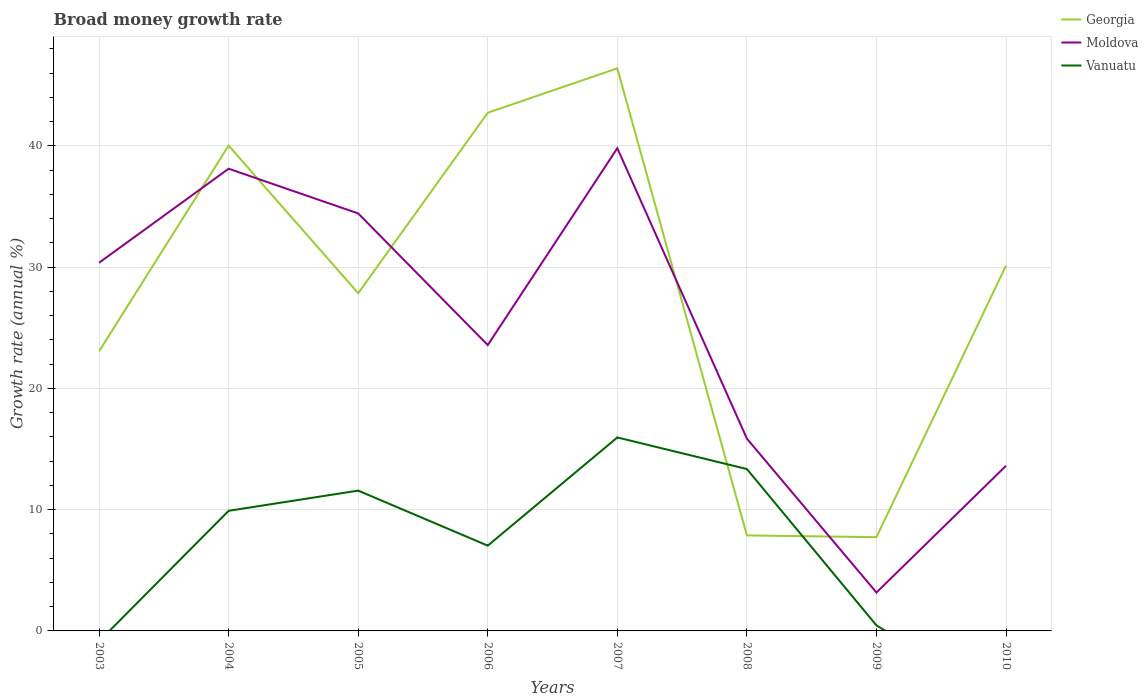Is the number of lines equal to the number of legend labels?
Make the answer very short. No. Across all years, what is the maximum growth rate in Vanuatu?
Your answer should be very brief. 0. What is the total growth rate in Moldova in the graph?
Offer a very short reply. 20.41. What is the difference between the highest and the second highest growth rate in Moldova?
Provide a short and direct response. 36.64. How many lines are there?
Your answer should be compact. 3. What is the difference between two consecutive major ticks on the Y-axis?
Provide a succinct answer. 10. Are the values on the major ticks of Y-axis written in scientific E-notation?
Your answer should be compact. No. How many legend labels are there?
Your answer should be compact. 3. How are the legend labels stacked?
Keep it short and to the point. Vertical. What is the title of the graph?
Offer a terse response. Broad money growth rate. Does "Portugal" appear as one of the legend labels in the graph?
Your answer should be very brief. No. What is the label or title of the X-axis?
Provide a succinct answer. Years. What is the label or title of the Y-axis?
Ensure brevity in your answer.  Growth rate (annual %). What is the Growth rate (annual %) of Georgia in 2003?
Your answer should be compact. 23.06. What is the Growth rate (annual %) in Moldova in 2003?
Ensure brevity in your answer.  30.37. What is the Growth rate (annual %) of Vanuatu in 2003?
Ensure brevity in your answer.  0. What is the Growth rate (annual %) in Georgia in 2004?
Offer a very short reply. 40.03. What is the Growth rate (annual %) of Moldova in 2004?
Ensure brevity in your answer.  38.12. What is the Growth rate (annual %) in Vanuatu in 2004?
Your answer should be very brief. 9.91. What is the Growth rate (annual %) in Georgia in 2005?
Your response must be concise. 27.85. What is the Growth rate (annual %) in Moldova in 2005?
Provide a short and direct response. 34.43. What is the Growth rate (annual %) in Vanuatu in 2005?
Keep it short and to the point. 11.57. What is the Growth rate (annual %) in Georgia in 2006?
Keep it short and to the point. 42.74. What is the Growth rate (annual %) in Moldova in 2006?
Make the answer very short. 23.58. What is the Growth rate (annual %) in Vanuatu in 2006?
Provide a short and direct response. 7.03. What is the Growth rate (annual %) in Georgia in 2007?
Make the answer very short. 46.4. What is the Growth rate (annual %) in Moldova in 2007?
Offer a very short reply. 39.81. What is the Growth rate (annual %) of Vanuatu in 2007?
Keep it short and to the point. 15.96. What is the Growth rate (annual %) of Georgia in 2008?
Ensure brevity in your answer.  7.88. What is the Growth rate (annual %) in Moldova in 2008?
Provide a short and direct response. 15.86. What is the Growth rate (annual %) of Vanuatu in 2008?
Your response must be concise. 13.35. What is the Growth rate (annual %) in Georgia in 2009?
Provide a succinct answer. 7.73. What is the Growth rate (annual %) in Moldova in 2009?
Your answer should be compact. 3.17. What is the Growth rate (annual %) of Vanuatu in 2009?
Provide a succinct answer. 0.46. What is the Growth rate (annual %) of Georgia in 2010?
Make the answer very short. 30.13. What is the Growth rate (annual %) of Moldova in 2010?
Provide a short and direct response. 13.62. What is the Growth rate (annual %) of Vanuatu in 2010?
Keep it short and to the point. 0. Across all years, what is the maximum Growth rate (annual %) of Georgia?
Give a very brief answer. 46.4. Across all years, what is the maximum Growth rate (annual %) in Moldova?
Your response must be concise. 39.81. Across all years, what is the maximum Growth rate (annual %) of Vanuatu?
Your answer should be compact. 15.96. Across all years, what is the minimum Growth rate (annual %) of Georgia?
Offer a very short reply. 7.73. Across all years, what is the minimum Growth rate (annual %) in Moldova?
Offer a terse response. 3.17. Across all years, what is the minimum Growth rate (annual %) in Vanuatu?
Offer a very short reply. 0. What is the total Growth rate (annual %) in Georgia in the graph?
Give a very brief answer. 225.82. What is the total Growth rate (annual %) in Moldova in the graph?
Give a very brief answer. 198.96. What is the total Growth rate (annual %) in Vanuatu in the graph?
Offer a very short reply. 58.28. What is the difference between the Growth rate (annual %) of Georgia in 2003 and that in 2004?
Provide a short and direct response. -16.97. What is the difference between the Growth rate (annual %) of Moldova in 2003 and that in 2004?
Ensure brevity in your answer.  -7.76. What is the difference between the Growth rate (annual %) in Georgia in 2003 and that in 2005?
Make the answer very short. -4.79. What is the difference between the Growth rate (annual %) of Moldova in 2003 and that in 2005?
Offer a very short reply. -4.07. What is the difference between the Growth rate (annual %) in Georgia in 2003 and that in 2006?
Make the answer very short. -19.67. What is the difference between the Growth rate (annual %) in Moldova in 2003 and that in 2006?
Keep it short and to the point. 6.79. What is the difference between the Growth rate (annual %) in Georgia in 2003 and that in 2007?
Your answer should be very brief. -23.34. What is the difference between the Growth rate (annual %) in Moldova in 2003 and that in 2007?
Give a very brief answer. -9.44. What is the difference between the Growth rate (annual %) of Georgia in 2003 and that in 2008?
Offer a terse response. 15.19. What is the difference between the Growth rate (annual %) in Moldova in 2003 and that in 2008?
Ensure brevity in your answer.  14.51. What is the difference between the Growth rate (annual %) of Georgia in 2003 and that in 2009?
Make the answer very short. 15.33. What is the difference between the Growth rate (annual %) of Moldova in 2003 and that in 2009?
Your answer should be very brief. 27.2. What is the difference between the Growth rate (annual %) of Georgia in 2003 and that in 2010?
Offer a very short reply. -7.07. What is the difference between the Growth rate (annual %) in Moldova in 2003 and that in 2010?
Your response must be concise. 16.74. What is the difference between the Growth rate (annual %) in Georgia in 2004 and that in 2005?
Offer a terse response. 12.18. What is the difference between the Growth rate (annual %) in Moldova in 2004 and that in 2005?
Ensure brevity in your answer.  3.69. What is the difference between the Growth rate (annual %) of Vanuatu in 2004 and that in 2005?
Provide a succinct answer. -1.66. What is the difference between the Growth rate (annual %) in Georgia in 2004 and that in 2006?
Your answer should be very brief. -2.71. What is the difference between the Growth rate (annual %) in Moldova in 2004 and that in 2006?
Make the answer very short. 14.55. What is the difference between the Growth rate (annual %) of Vanuatu in 2004 and that in 2006?
Your answer should be very brief. 2.87. What is the difference between the Growth rate (annual %) of Georgia in 2004 and that in 2007?
Your answer should be very brief. -6.37. What is the difference between the Growth rate (annual %) in Moldova in 2004 and that in 2007?
Your response must be concise. -1.69. What is the difference between the Growth rate (annual %) of Vanuatu in 2004 and that in 2007?
Offer a very short reply. -6.05. What is the difference between the Growth rate (annual %) of Georgia in 2004 and that in 2008?
Ensure brevity in your answer.  32.15. What is the difference between the Growth rate (annual %) in Moldova in 2004 and that in 2008?
Offer a terse response. 22.26. What is the difference between the Growth rate (annual %) in Vanuatu in 2004 and that in 2008?
Keep it short and to the point. -3.44. What is the difference between the Growth rate (annual %) in Georgia in 2004 and that in 2009?
Offer a very short reply. 32.3. What is the difference between the Growth rate (annual %) of Moldova in 2004 and that in 2009?
Give a very brief answer. 34.95. What is the difference between the Growth rate (annual %) of Vanuatu in 2004 and that in 2009?
Provide a succinct answer. 9.45. What is the difference between the Growth rate (annual %) of Georgia in 2004 and that in 2010?
Offer a very short reply. 9.9. What is the difference between the Growth rate (annual %) in Moldova in 2004 and that in 2010?
Offer a terse response. 24.5. What is the difference between the Growth rate (annual %) in Georgia in 2005 and that in 2006?
Keep it short and to the point. -14.88. What is the difference between the Growth rate (annual %) in Moldova in 2005 and that in 2006?
Ensure brevity in your answer.  10.86. What is the difference between the Growth rate (annual %) of Vanuatu in 2005 and that in 2006?
Your answer should be very brief. 4.54. What is the difference between the Growth rate (annual %) of Georgia in 2005 and that in 2007?
Your answer should be compact. -18.55. What is the difference between the Growth rate (annual %) in Moldova in 2005 and that in 2007?
Provide a short and direct response. -5.38. What is the difference between the Growth rate (annual %) in Vanuatu in 2005 and that in 2007?
Keep it short and to the point. -4.38. What is the difference between the Growth rate (annual %) in Georgia in 2005 and that in 2008?
Your answer should be very brief. 19.97. What is the difference between the Growth rate (annual %) of Moldova in 2005 and that in 2008?
Ensure brevity in your answer.  18.57. What is the difference between the Growth rate (annual %) in Vanuatu in 2005 and that in 2008?
Offer a terse response. -1.78. What is the difference between the Growth rate (annual %) of Georgia in 2005 and that in 2009?
Your response must be concise. 20.12. What is the difference between the Growth rate (annual %) in Moldova in 2005 and that in 2009?
Your response must be concise. 31.27. What is the difference between the Growth rate (annual %) of Vanuatu in 2005 and that in 2009?
Your answer should be compact. 11.12. What is the difference between the Growth rate (annual %) of Georgia in 2005 and that in 2010?
Your answer should be very brief. -2.28. What is the difference between the Growth rate (annual %) of Moldova in 2005 and that in 2010?
Provide a succinct answer. 20.81. What is the difference between the Growth rate (annual %) of Georgia in 2006 and that in 2007?
Offer a terse response. -3.66. What is the difference between the Growth rate (annual %) in Moldova in 2006 and that in 2007?
Keep it short and to the point. -16.23. What is the difference between the Growth rate (annual %) in Vanuatu in 2006 and that in 2007?
Ensure brevity in your answer.  -8.92. What is the difference between the Growth rate (annual %) in Georgia in 2006 and that in 2008?
Offer a terse response. 34.86. What is the difference between the Growth rate (annual %) of Moldova in 2006 and that in 2008?
Your answer should be very brief. 7.72. What is the difference between the Growth rate (annual %) of Vanuatu in 2006 and that in 2008?
Your answer should be very brief. -6.32. What is the difference between the Growth rate (annual %) in Georgia in 2006 and that in 2009?
Your answer should be very brief. 35. What is the difference between the Growth rate (annual %) in Moldova in 2006 and that in 2009?
Your answer should be very brief. 20.41. What is the difference between the Growth rate (annual %) of Vanuatu in 2006 and that in 2009?
Offer a terse response. 6.58. What is the difference between the Growth rate (annual %) of Georgia in 2006 and that in 2010?
Give a very brief answer. 12.6. What is the difference between the Growth rate (annual %) in Moldova in 2006 and that in 2010?
Ensure brevity in your answer.  9.95. What is the difference between the Growth rate (annual %) in Georgia in 2007 and that in 2008?
Your answer should be very brief. 38.52. What is the difference between the Growth rate (annual %) of Moldova in 2007 and that in 2008?
Offer a terse response. 23.95. What is the difference between the Growth rate (annual %) in Vanuatu in 2007 and that in 2008?
Your response must be concise. 2.61. What is the difference between the Growth rate (annual %) of Georgia in 2007 and that in 2009?
Offer a very short reply. 38.67. What is the difference between the Growth rate (annual %) of Moldova in 2007 and that in 2009?
Give a very brief answer. 36.64. What is the difference between the Growth rate (annual %) of Vanuatu in 2007 and that in 2009?
Offer a terse response. 15.5. What is the difference between the Growth rate (annual %) of Georgia in 2007 and that in 2010?
Make the answer very short. 16.27. What is the difference between the Growth rate (annual %) of Moldova in 2007 and that in 2010?
Keep it short and to the point. 26.19. What is the difference between the Growth rate (annual %) of Georgia in 2008 and that in 2009?
Your answer should be compact. 0.14. What is the difference between the Growth rate (annual %) of Moldova in 2008 and that in 2009?
Make the answer very short. 12.69. What is the difference between the Growth rate (annual %) of Vanuatu in 2008 and that in 2009?
Your answer should be very brief. 12.9. What is the difference between the Growth rate (annual %) in Georgia in 2008 and that in 2010?
Keep it short and to the point. -22.26. What is the difference between the Growth rate (annual %) of Moldova in 2008 and that in 2010?
Offer a very short reply. 2.24. What is the difference between the Growth rate (annual %) of Georgia in 2009 and that in 2010?
Offer a terse response. -22.4. What is the difference between the Growth rate (annual %) in Moldova in 2009 and that in 2010?
Your answer should be very brief. -10.45. What is the difference between the Growth rate (annual %) of Georgia in 2003 and the Growth rate (annual %) of Moldova in 2004?
Keep it short and to the point. -15.06. What is the difference between the Growth rate (annual %) of Georgia in 2003 and the Growth rate (annual %) of Vanuatu in 2004?
Make the answer very short. 13.15. What is the difference between the Growth rate (annual %) of Moldova in 2003 and the Growth rate (annual %) of Vanuatu in 2004?
Provide a short and direct response. 20.46. What is the difference between the Growth rate (annual %) in Georgia in 2003 and the Growth rate (annual %) in Moldova in 2005?
Offer a very short reply. -11.37. What is the difference between the Growth rate (annual %) in Georgia in 2003 and the Growth rate (annual %) in Vanuatu in 2005?
Offer a very short reply. 11.49. What is the difference between the Growth rate (annual %) of Moldova in 2003 and the Growth rate (annual %) of Vanuatu in 2005?
Your response must be concise. 18.79. What is the difference between the Growth rate (annual %) of Georgia in 2003 and the Growth rate (annual %) of Moldova in 2006?
Your answer should be compact. -0.51. What is the difference between the Growth rate (annual %) of Georgia in 2003 and the Growth rate (annual %) of Vanuatu in 2006?
Make the answer very short. 16.03. What is the difference between the Growth rate (annual %) of Moldova in 2003 and the Growth rate (annual %) of Vanuatu in 2006?
Ensure brevity in your answer.  23.33. What is the difference between the Growth rate (annual %) in Georgia in 2003 and the Growth rate (annual %) in Moldova in 2007?
Offer a terse response. -16.75. What is the difference between the Growth rate (annual %) of Georgia in 2003 and the Growth rate (annual %) of Vanuatu in 2007?
Offer a very short reply. 7.11. What is the difference between the Growth rate (annual %) of Moldova in 2003 and the Growth rate (annual %) of Vanuatu in 2007?
Your answer should be compact. 14.41. What is the difference between the Growth rate (annual %) in Georgia in 2003 and the Growth rate (annual %) in Moldova in 2008?
Provide a short and direct response. 7.2. What is the difference between the Growth rate (annual %) of Georgia in 2003 and the Growth rate (annual %) of Vanuatu in 2008?
Offer a terse response. 9.71. What is the difference between the Growth rate (annual %) of Moldova in 2003 and the Growth rate (annual %) of Vanuatu in 2008?
Your answer should be very brief. 17.01. What is the difference between the Growth rate (annual %) in Georgia in 2003 and the Growth rate (annual %) in Moldova in 2009?
Your response must be concise. 19.89. What is the difference between the Growth rate (annual %) in Georgia in 2003 and the Growth rate (annual %) in Vanuatu in 2009?
Offer a very short reply. 22.61. What is the difference between the Growth rate (annual %) of Moldova in 2003 and the Growth rate (annual %) of Vanuatu in 2009?
Your response must be concise. 29.91. What is the difference between the Growth rate (annual %) of Georgia in 2003 and the Growth rate (annual %) of Moldova in 2010?
Provide a short and direct response. 9.44. What is the difference between the Growth rate (annual %) in Georgia in 2004 and the Growth rate (annual %) in Moldova in 2005?
Ensure brevity in your answer.  5.6. What is the difference between the Growth rate (annual %) of Georgia in 2004 and the Growth rate (annual %) of Vanuatu in 2005?
Give a very brief answer. 28.46. What is the difference between the Growth rate (annual %) in Moldova in 2004 and the Growth rate (annual %) in Vanuatu in 2005?
Keep it short and to the point. 26.55. What is the difference between the Growth rate (annual %) of Georgia in 2004 and the Growth rate (annual %) of Moldova in 2006?
Keep it short and to the point. 16.45. What is the difference between the Growth rate (annual %) of Georgia in 2004 and the Growth rate (annual %) of Vanuatu in 2006?
Offer a very short reply. 33. What is the difference between the Growth rate (annual %) in Moldova in 2004 and the Growth rate (annual %) in Vanuatu in 2006?
Give a very brief answer. 31.09. What is the difference between the Growth rate (annual %) in Georgia in 2004 and the Growth rate (annual %) in Moldova in 2007?
Provide a succinct answer. 0.22. What is the difference between the Growth rate (annual %) of Georgia in 2004 and the Growth rate (annual %) of Vanuatu in 2007?
Ensure brevity in your answer.  24.07. What is the difference between the Growth rate (annual %) of Moldova in 2004 and the Growth rate (annual %) of Vanuatu in 2007?
Provide a succinct answer. 22.16. What is the difference between the Growth rate (annual %) of Georgia in 2004 and the Growth rate (annual %) of Moldova in 2008?
Make the answer very short. 24.17. What is the difference between the Growth rate (annual %) of Georgia in 2004 and the Growth rate (annual %) of Vanuatu in 2008?
Keep it short and to the point. 26.68. What is the difference between the Growth rate (annual %) in Moldova in 2004 and the Growth rate (annual %) in Vanuatu in 2008?
Provide a short and direct response. 24.77. What is the difference between the Growth rate (annual %) of Georgia in 2004 and the Growth rate (annual %) of Moldova in 2009?
Offer a very short reply. 36.86. What is the difference between the Growth rate (annual %) in Georgia in 2004 and the Growth rate (annual %) in Vanuatu in 2009?
Ensure brevity in your answer.  39.57. What is the difference between the Growth rate (annual %) in Moldova in 2004 and the Growth rate (annual %) in Vanuatu in 2009?
Make the answer very short. 37.66. What is the difference between the Growth rate (annual %) in Georgia in 2004 and the Growth rate (annual %) in Moldova in 2010?
Your answer should be compact. 26.41. What is the difference between the Growth rate (annual %) in Georgia in 2005 and the Growth rate (annual %) in Moldova in 2006?
Your answer should be compact. 4.28. What is the difference between the Growth rate (annual %) in Georgia in 2005 and the Growth rate (annual %) in Vanuatu in 2006?
Your answer should be very brief. 20.82. What is the difference between the Growth rate (annual %) of Moldova in 2005 and the Growth rate (annual %) of Vanuatu in 2006?
Give a very brief answer. 27.4. What is the difference between the Growth rate (annual %) in Georgia in 2005 and the Growth rate (annual %) in Moldova in 2007?
Your response must be concise. -11.96. What is the difference between the Growth rate (annual %) in Georgia in 2005 and the Growth rate (annual %) in Vanuatu in 2007?
Offer a terse response. 11.89. What is the difference between the Growth rate (annual %) in Moldova in 2005 and the Growth rate (annual %) in Vanuatu in 2007?
Provide a short and direct response. 18.48. What is the difference between the Growth rate (annual %) in Georgia in 2005 and the Growth rate (annual %) in Moldova in 2008?
Your response must be concise. 11.99. What is the difference between the Growth rate (annual %) of Georgia in 2005 and the Growth rate (annual %) of Vanuatu in 2008?
Provide a succinct answer. 14.5. What is the difference between the Growth rate (annual %) in Moldova in 2005 and the Growth rate (annual %) in Vanuatu in 2008?
Ensure brevity in your answer.  21.08. What is the difference between the Growth rate (annual %) of Georgia in 2005 and the Growth rate (annual %) of Moldova in 2009?
Offer a terse response. 24.68. What is the difference between the Growth rate (annual %) of Georgia in 2005 and the Growth rate (annual %) of Vanuatu in 2009?
Your response must be concise. 27.4. What is the difference between the Growth rate (annual %) in Moldova in 2005 and the Growth rate (annual %) in Vanuatu in 2009?
Provide a succinct answer. 33.98. What is the difference between the Growth rate (annual %) of Georgia in 2005 and the Growth rate (annual %) of Moldova in 2010?
Offer a terse response. 14.23. What is the difference between the Growth rate (annual %) in Georgia in 2006 and the Growth rate (annual %) in Moldova in 2007?
Your response must be concise. 2.93. What is the difference between the Growth rate (annual %) in Georgia in 2006 and the Growth rate (annual %) in Vanuatu in 2007?
Offer a terse response. 26.78. What is the difference between the Growth rate (annual %) in Moldova in 2006 and the Growth rate (annual %) in Vanuatu in 2007?
Your response must be concise. 7.62. What is the difference between the Growth rate (annual %) of Georgia in 2006 and the Growth rate (annual %) of Moldova in 2008?
Offer a very short reply. 26.88. What is the difference between the Growth rate (annual %) in Georgia in 2006 and the Growth rate (annual %) in Vanuatu in 2008?
Your answer should be compact. 29.39. What is the difference between the Growth rate (annual %) of Moldova in 2006 and the Growth rate (annual %) of Vanuatu in 2008?
Keep it short and to the point. 10.22. What is the difference between the Growth rate (annual %) of Georgia in 2006 and the Growth rate (annual %) of Moldova in 2009?
Give a very brief answer. 39.57. What is the difference between the Growth rate (annual %) of Georgia in 2006 and the Growth rate (annual %) of Vanuatu in 2009?
Your response must be concise. 42.28. What is the difference between the Growth rate (annual %) in Moldova in 2006 and the Growth rate (annual %) in Vanuatu in 2009?
Ensure brevity in your answer.  23.12. What is the difference between the Growth rate (annual %) in Georgia in 2006 and the Growth rate (annual %) in Moldova in 2010?
Give a very brief answer. 29.11. What is the difference between the Growth rate (annual %) in Georgia in 2007 and the Growth rate (annual %) in Moldova in 2008?
Offer a very short reply. 30.54. What is the difference between the Growth rate (annual %) of Georgia in 2007 and the Growth rate (annual %) of Vanuatu in 2008?
Provide a succinct answer. 33.05. What is the difference between the Growth rate (annual %) in Moldova in 2007 and the Growth rate (annual %) in Vanuatu in 2008?
Provide a short and direct response. 26.46. What is the difference between the Growth rate (annual %) in Georgia in 2007 and the Growth rate (annual %) in Moldova in 2009?
Provide a short and direct response. 43.23. What is the difference between the Growth rate (annual %) of Georgia in 2007 and the Growth rate (annual %) of Vanuatu in 2009?
Provide a short and direct response. 45.94. What is the difference between the Growth rate (annual %) of Moldova in 2007 and the Growth rate (annual %) of Vanuatu in 2009?
Provide a succinct answer. 39.35. What is the difference between the Growth rate (annual %) in Georgia in 2007 and the Growth rate (annual %) in Moldova in 2010?
Your answer should be compact. 32.78. What is the difference between the Growth rate (annual %) in Georgia in 2008 and the Growth rate (annual %) in Moldova in 2009?
Your response must be concise. 4.71. What is the difference between the Growth rate (annual %) in Georgia in 2008 and the Growth rate (annual %) in Vanuatu in 2009?
Offer a very short reply. 7.42. What is the difference between the Growth rate (annual %) of Moldova in 2008 and the Growth rate (annual %) of Vanuatu in 2009?
Your answer should be compact. 15.4. What is the difference between the Growth rate (annual %) of Georgia in 2008 and the Growth rate (annual %) of Moldova in 2010?
Provide a short and direct response. -5.75. What is the difference between the Growth rate (annual %) in Georgia in 2009 and the Growth rate (annual %) in Moldova in 2010?
Offer a very short reply. -5.89. What is the average Growth rate (annual %) in Georgia per year?
Your response must be concise. 28.23. What is the average Growth rate (annual %) of Moldova per year?
Ensure brevity in your answer.  24.87. What is the average Growth rate (annual %) of Vanuatu per year?
Provide a short and direct response. 7.28. In the year 2003, what is the difference between the Growth rate (annual %) in Georgia and Growth rate (annual %) in Moldova?
Keep it short and to the point. -7.3. In the year 2004, what is the difference between the Growth rate (annual %) in Georgia and Growth rate (annual %) in Moldova?
Provide a short and direct response. 1.91. In the year 2004, what is the difference between the Growth rate (annual %) of Georgia and Growth rate (annual %) of Vanuatu?
Provide a short and direct response. 30.12. In the year 2004, what is the difference between the Growth rate (annual %) of Moldova and Growth rate (annual %) of Vanuatu?
Your answer should be compact. 28.21. In the year 2005, what is the difference between the Growth rate (annual %) of Georgia and Growth rate (annual %) of Moldova?
Your answer should be very brief. -6.58. In the year 2005, what is the difference between the Growth rate (annual %) of Georgia and Growth rate (annual %) of Vanuatu?
Your answer should be compact. 16.28. In the year 2005, what is the difference between the Growth rate (annual %) in Moldova and Growth rate (annual %) in Vanuatu?
Provide a short and direct response. 22.86. In the year 2006, what is the difference between the Growth rate (annual %) of Georgia and Growth rate (annual %) of Moldova?
Make the answer very short. 19.16. In the year 2006, what is the difference between the Growth rate (annual %) of Georgia and Growth rate (annual %) of Vanuatu?
Give a very brief answer. 35.7. In the year 2006, what is the difference between the Growth rate (annual %) in Moldova and Growth rate (annual %) in Vanuatu?
Offer a very short reply. 16.54. In the year 2007, what is the difference between the Growth rate (annual %) of Georgia and Growth rate (annual %) of Moldova?
Provide a succinct answer. 6.59. In the year 2007, what is the difference between the Growth rate (annual %) of Georgia and Growth rate (annual %) of Vanuatu?
Ensure brevity in your answer.  30.44. In the year 2007, what is the difference between the Growth rate (annual %) in Moldova and Growth rate (annual %) in Vanuatu?
Your answer should be compact. 23.85. In the year 2008, what is the difference between the Growth rate (annual %) of Georgia and Growth rate (annual %) of Moldova?
Keep it short and to the point. -7.98. In the year 2008, what is the difference between the Growth rate (annual %) of Georgia and Growth rate (annual %) of Vanuatu?
Offer a terse response. -5.47. In the year 2008, what is the difference between the Growth rate (annual %) in Moldova and Growth rate (annual %) in Vanuatu?
Keep it short and to the point. 2.51. In the year 2009, what is the difference between the Growth rate (annual %) of Georgia and Growth rate (annual %) of Moldova?
Offer a terse response. 4.56. In the year 2009, what is the difference between the Growth rate (annual %) of Georgia and Growth rate (annual %) of Vanuatu?
Make the answer very short. 7.28. In the year 2009, what is the difference between the Growth rate (annual %) in Moldova and Growth rate (annual %) in Vanuatu?
Give a very brief answer. 2.71. In the year 2010, what is the difference between the Growth rate (annual %) of Georgia and Growth rate (annual %) of Moldova?
Your response must be concise. 16.51. What is the ratio of the Growth rate (annual %) of Georgia in 2003 to that in 2004?
Provide a short and direct response. 0.58. What is the ratio of the Growth rate (annual %) in Moldova in 2003 to that in 2004?
Offer a very short reply. 0.8. What is the ratio of the Growth rate (annual %) in Georgia in 2003 to that in 2005?
Provide a short and direct response. 0.83. What is the ratio of the Growth rate (annual %) of Moldova in 2003 to that in 2005?
Provide a succinct answer. 0.88. What is the ratio of the Growth rate (annual %) in Georgia in 2003 to that in 2006?
Offer a very short reply. 0.54. What is the ratio of the Growth rate (annual %) of Moldova in 2003 to that in 2006?
Provide a short and direct response. 1.29. What is the ratio of the Growth rate (annual %) in Georgia in 2003 to that in 2007?
Provide a short and direct response. 0.5. What is the ratio of the Growth rate (annual %) of Moldova in 2003 to that in 2007?
Make the answer very short. 0.76. What is the ratio of the Growth rate (annual %) in Georgia in 2003 to that in 2008?
Your answer should be very brief. 2.93. What is the ratio of the Growth rate (annual %) of Moldova in 2003 to that in 2008?
Your response must be concise. 1.91. What is the ratio of the Growth rate (annual %) of Georgia in 2003 to that in 2009?
Your answer should be compact. 2.98. What is the ratio of the Growth rate (annual %) in Moldova in 2003 to that in 2009?
Ensure brevity in your answer.  9.58. What is the ratio of the Growth rate (annual %) in Georgia in 2003 to that in 2010?
Make the answer very short. 0.77. What is the ratio of the Growth rate (annual %) in Moldova in 2003 to that in 2010?
Your answer should be very brief. 2.23. What is the ratio of the Growth rate (annual %) in Georgia in 2004 to that in 2005?
Keep it short and to the point. 1.44. What is the ratio of the Growth rate (annual %) of Moldova in 2004 to that in 2005?
Give a very brief answer. 1.11. What is the ratio of the Growth rate (annual %) of Vanuatu in 2004 to that in 2005?
Ensure brevity in your answer.  0.86. What is the ratio of the Growth rate (annual %) in Georgia in 2004 to that in 2006?
Make the answer very short. 0.94. What is the ratio of the Growth rate (annual %) of Moldova in 2004 to that in 2006?
Your response must be concise. 1.62. What is the ratio of the Growth rate (annual %) of Vanuatu in 2004 to that in 2006?
Keep it short and to the point. 1.41. What is the ratio of the Growth rate (annual %) in Georgia in 2004 to that in 2007?
Your answer should be compact. 0.86. What is the ratio of the Growth rate (annual %) of Moldova in 2004 to that in 2007?
Your answer should be very brief. 0.96. What is the ratio of the Growth rate (annual %) of Vanuatu in 2004 to that in 2007?
Your response must be concise. 0.62. What is the ratio of the Growth rate (annual %) of Georgia in 2004 to that in 2008?
Offer a very short reply. 5.08. What is the ratio of the Growth rate (annual %) in Moldova in 2004 to that in 2008?
Provide a succinct answer. 2.4. What is the ratio of the Growth rate (annual %) in Vanuatu in 2004 to that in 2008?
Provide a succinct answer. 0.74. What is the ratio of the Growth rate (annual %) in Georgia in 2004 to that in 2009?
Your answer should be very brief. 5.18. What is the ratio of the Growth rate (annual %) of Moldova in 2004 to that in 2009?
Provide a short and direct response. 12.03. What is the ratio of the Growth rate (annual %) in Vanuatu in 2004 to that in 2009?
Make the answer very short. 21.72. What is the ratio of the Growth rate (annual %) of Georgia in 2004 to that in 2010?
Your response must be concise. 1.33. What is the ratio of the Growth rate (annual %) of Moldova in 2004 to that in 2010?
Ensure brevity in your answer.  2.8. What is the ratio of the Growth rate (annual %) in Georgia in 2005 to that in 2006?
Keep it short and to the point. 0.65. What is the ratio of the Growth rate (annual %) in Moldova in 2005 to that in 2006?
Give a very brief answer. 1.46. What is the ratio of the Growth rate (annual %) in Vanuatu in 2005 to that in 2006?
Ensure brevity in your answer.  1.65. What is the ratio of the Growth rate (annual %) of Georgia in 2005 to that in 2007?
Provide a succinct answer. 0.6. What is the ratio of the Growth rate (annual %) of Moldova in 2005 to that in 2007?
Your response must be concise. 0.86. What is the ratio of the Growth rate (annual %) of Vanuatu in 2005 to that in 2007?
Keep it short and to the point. 0.73. What is the ratio of the Growth rate (annual %) in Georgia in 2005 to that in 2008?
Give a very brief answer. 3.54. What is the ratio of the Growth rate (annual %) of Moldova in 2005 to that in 2008?
Ensure brevity in your answer.  2.17. What is the ratio of the Growth rate (annual %) in Vanuatu in 2005 to that in 2008?
Provide a short and direct response. 0.87. What is the ratio of the Growth rate (annual %) in Georgia in 2005 to that in 2009?
Give a very brief answer. 3.6. What is the ratio of the Growth rate (annual %) in Moldova in 2005 to that in 2009?
Provide a succinct answer. 10.87. What is the ratio of the Growth rate (annual %) in Vanuatu in 2005 to that in 2009?
Your response must be concise. 25.37. What is the ratio of the Growth rate (annual %) of Georgia in 2005 to that in 2010?
Provide a short and direct response. 0.92. What is the ratio of the Growth rate (annual %) in Moldova in 2005 to that in 2010?
Provide a short and direct response. 2.53. What is the ratio of the Growth rate (annual %) in Georgia in 2006 to that in 2007?
Keep it short and to the point. 0.92. What is the ratio of the Growth rate (annual %) in Moldova in 2006 to that in 2007?
Provide a succinct answer. 0.59. What is the ratio of the Growth rate (annual %) in Vanuatu in 2006 to that in 2007?
Give a very brief answer. 0.44. What is the ratio of the Growth rate (annual %) in Georgia in 2006 to that in 2008?
Offer a terse response. 5.43. What is the ratio of the Growth rate (annual %) of Moldova in 2006 to that in 2008?
Make the answer very short. 1.49. What is the ratio of the Growth rate (annual %) of Vanuatu in 2006 to that in 2008?
Your answer should be very brief. 0.53. What is the ratio of the Growth rate (annual %) of Georgia in 2006 to that in 2009?
Provide a succinct answer. 5.53. What is the ratio of the Growth rate (annual %) of Moldova in 2006 to that in 2009?
Your answer should be compact. 7.44. What is the ratio of the Growth rate (annual %) of Vanuatu in 2006 to that in 2009?
Your response must be concise. 15.42. What is the ratio of the Growth rate (annual %) of Georgia in 2006 to that in 2010?
Your response must be concise. 1.42. What is the ratio of the Growth rate (annual %) in Moldova in 2006 to that in 2010?
Your answer should be very brief. 1.73. What is the ratio of the Growth rate (annual %) in Georgia in 2007 to that in 2008?
Provide a succinct answer. 5.89. What is the ratio of the Growth rate (annual %) of Moldova in 2007 to that in 2008?
Provide a short and direct response. 2.51. What is the ratio of the Growth rate (annual %) in Vanuatu in 2007 to that in 2008?
Your response must be concise. 1.2. What is the ratio of the Growth rate (annual %) in Georgia in 2007 to that in 2009?
Your response must be concise. 6. What is the ratio of the Growth rate (annual %) of Moldova in 2007 to that in 2009?
Provide a succinct answer. 12.57. What is the ratio of the Growth rate (annual %) in Vanuatu in 2007 to that in 2009?
Ensure brevity in your answer.  34.99. What is the ratio of the Growth rate (annual %) of Georgia in 2007 to that in 2010?
Ensure brevity in your answer.  1.54. What is the ratio of the Growth rate (annual %) of Moldova in 2007 to that in 2010?
Make the answer very short. 2.92. What is the ratio of the Growth rate (annual %) in Georgia in 2008 to that in 2009?
Ensure brevity in your answer.  1.02. What is the ratio of the Growth rate (annual %) in Moldova in 2008 to that in 2009?
Make the answer very short. 5.01. What is the ratio of the Growth rate (annual %) of Vanuatu in 2008 to that in 2009?
Your answer should be compact. 29.27. What is the ratio of the Growth rate (annual %) of Georgia in 2008 to that in 2010?
Make the answer very short. 0.26. What is the ratio of the Growth rate (annual %) of Moldova in 2008 to that in 2010?
Offer a terse response. 1.16. What is the ratio of the Growth rate (annual %) of Georgia in 2009 to that in 2010?
Give a very brief answer. 0.26. What is the ratio of the Growth rate (annual %) in Moldova in 2009 to that in 2010?
Give a very brief answer. 0.23. What is the difference between the highest and the second highest Growth rate (annual %) of Georgia?
Make the answer very short. 3.66. What is the difference between the highest and the second highest Growth rate (annual %) in Moldova?
Make the answer very short. 1.69. What is the difference between the highest and the second highest Growth rate (annual %) of Vanuatu?
Offer a terse response. 2.61. What is the difference between the highest and the lowest Growth rate (annual %) in Georgia?
Your response must be concise. 38.67. What is the difference between the highest and the lowest Growth rate (annual %) in Moldova?
Make the answer very short. 36.64. What is the difference between the highest and the lowest Growth rate (annual %) in Vanuatu?
Provide a succinct answer. 15.96. 